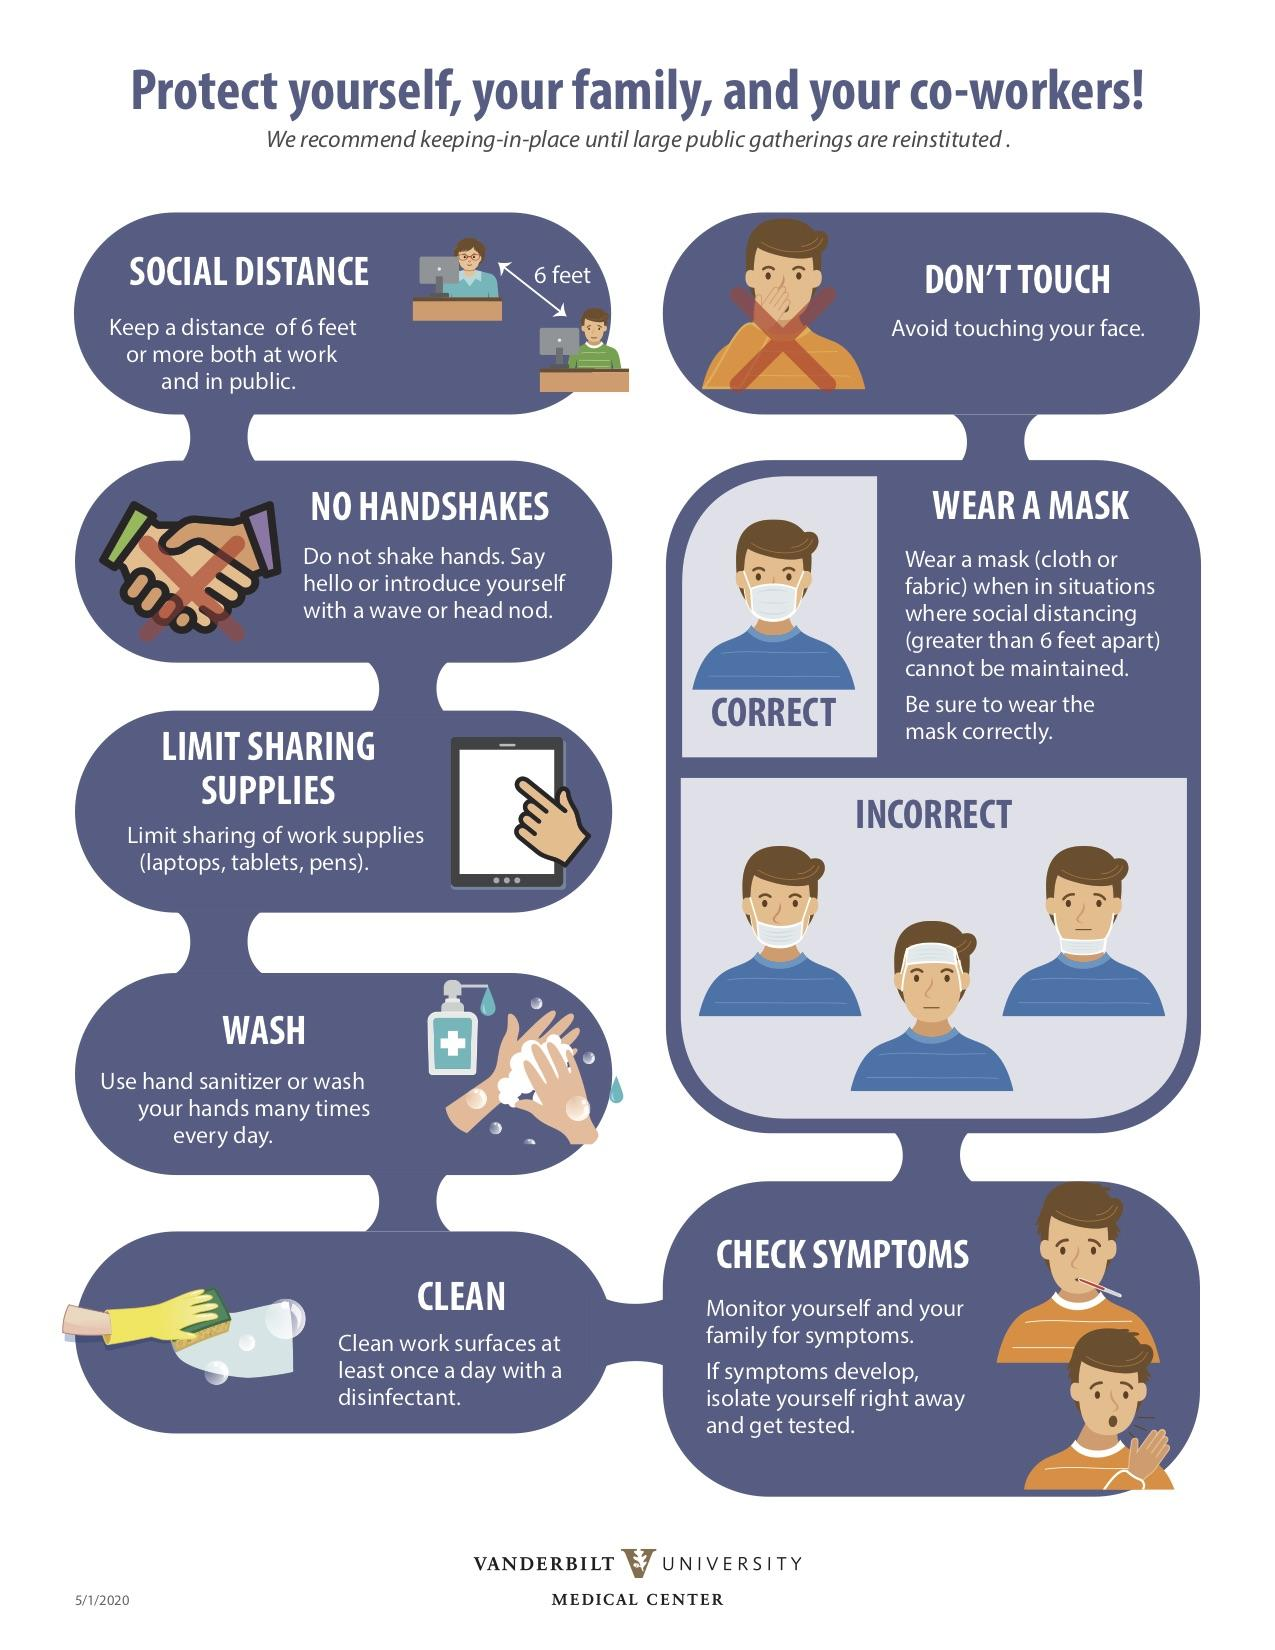Give some essential details in this illustration. The third prevention measure is to check symptoms, which is located at the right side. Given the prevention measures on the left side, the second measure is no handshakes. The fourth prevention measure listed on the left is washing. The second prevention measure is to wear a mask. This infographic provides 8 prevention measures. 